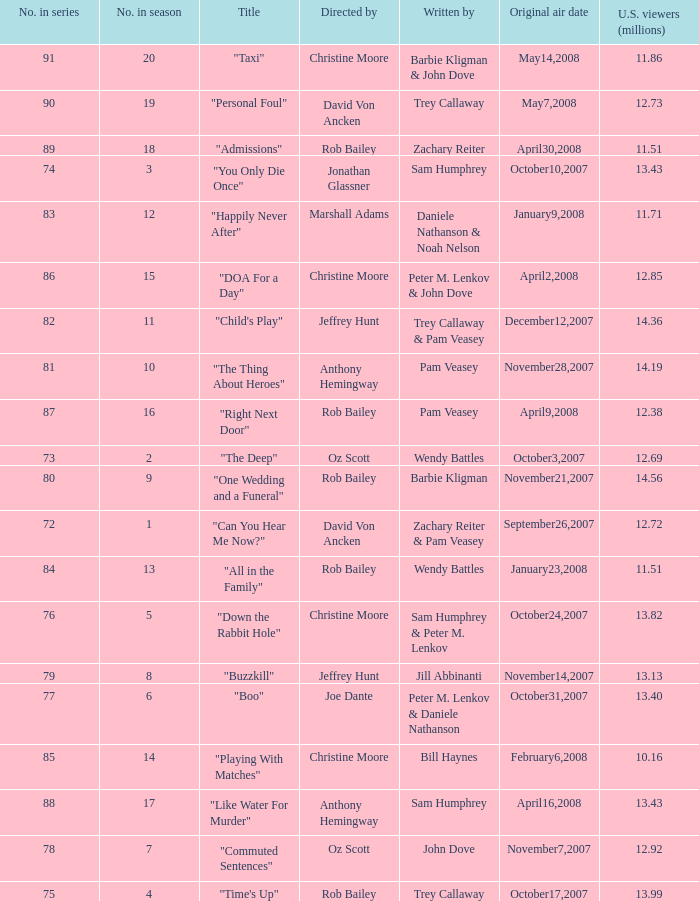How many millions of u.s. watchers viewed the episode "buzzkill"? 1.0. 